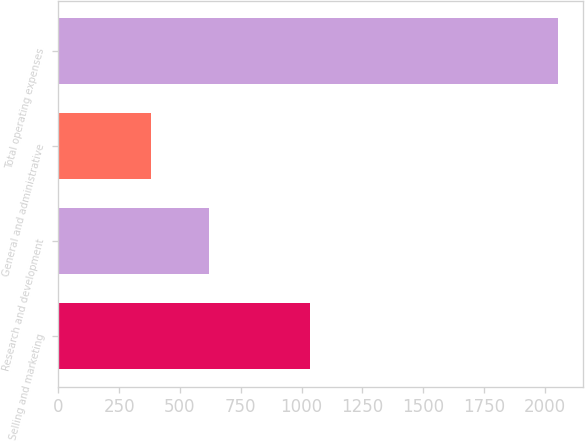<chart> <loc_0><loc_0><loc_500><loc_500><bar_chart><fcel>Selling and marketing<fcel>Research and development<fcel>General and administrative<fcel>Total operating expenses<nl><fcel>1033<fcel>618<fcel>381<fcel>2055<nl></chart> 